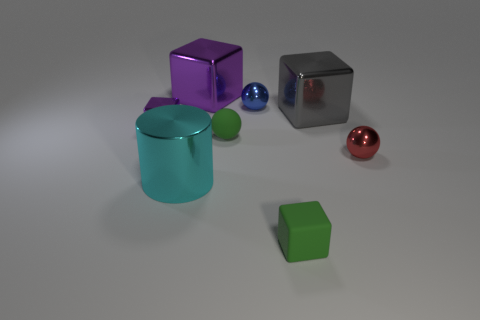Subtract 1 blocks. How many blocks are left? 3 Add 1 big cyan objects. How many objects exist? 9 Subtract all spheres. How many objects are left? 5 Add 5 large cyan matte cylinders. How many large cyan matte cylinders exist? 5 Subtract 0 blue cubes. How many objects are left? 8 Subtract all small red things. Subtract all large metallic cylinders. How many objects are left? 6 Add 4 big metallic cylinders. How many big metallic cylinders are left? 5 